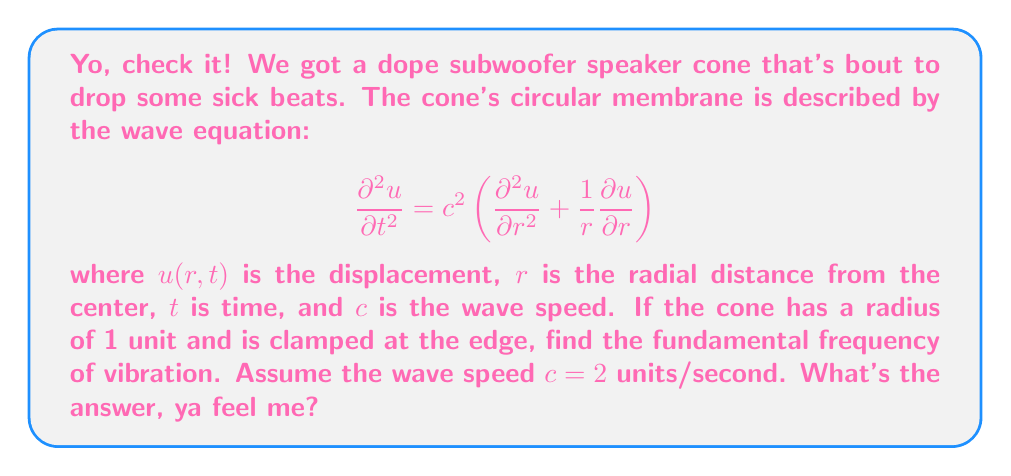Show me your answer to this math problem. Aight, let's break it down, Lil Jon style:

1) First, we gotta separate our variables, ya heard? Let $u(r,t) = R(r)T(t)$.

2) Pluggin' this into our wave equation, we get:

   $$R(r)T''(t) = c^2\left(R''(r)T(t) + \frac{1}{r}R'(r)T(t)\right)$$

3) Dividin' both sides by $RT$, we get:

   $$\frac{T''(t)}{T(t)} = c^2\left(\frac{R''(r)}{R(r)} + \frac{1}{r}\frac{R'(r)}{R(r)}\right) = -\lambda^2$$

   where $\lambda^2$ is our separation constant.

4) For the time part, we get:
   $$T(t) = A\cos(\lambda ct) + B\sin(\lambda ct)$$

5) For the spatial part, we get Bessel's equation:
   $$r^2R''(r) + rR'(r) + \lambda^2r^2R(r) = 0$$

6) The solution to this is:
   $$R(r) = CJ_0(\lambda r)$$
   where $J_0$ is the Bessel function of the first kind of order zero.

7) Now, the boundary condition says $R(1) = 0$ (clamped at the edge, yo). This means:
   $$J_0(\lambda) = 0$$

8) The smallest positive root of this equation is approximately $\lambda \approx 2.4048$.

9) The fundamental frequency $f$ is given by:
   $$f = \frac{\lambda c}{2\pi}$$

10) Pluggin' in our values:
    $$f = \frac{2.4048 \cdot 2}{2\pi} \approx 0.7652$$

And that's how we drop the bass, Lil Jon style!
Answer: The fundamental frequency is approximately 0.7652 units^(-1). 